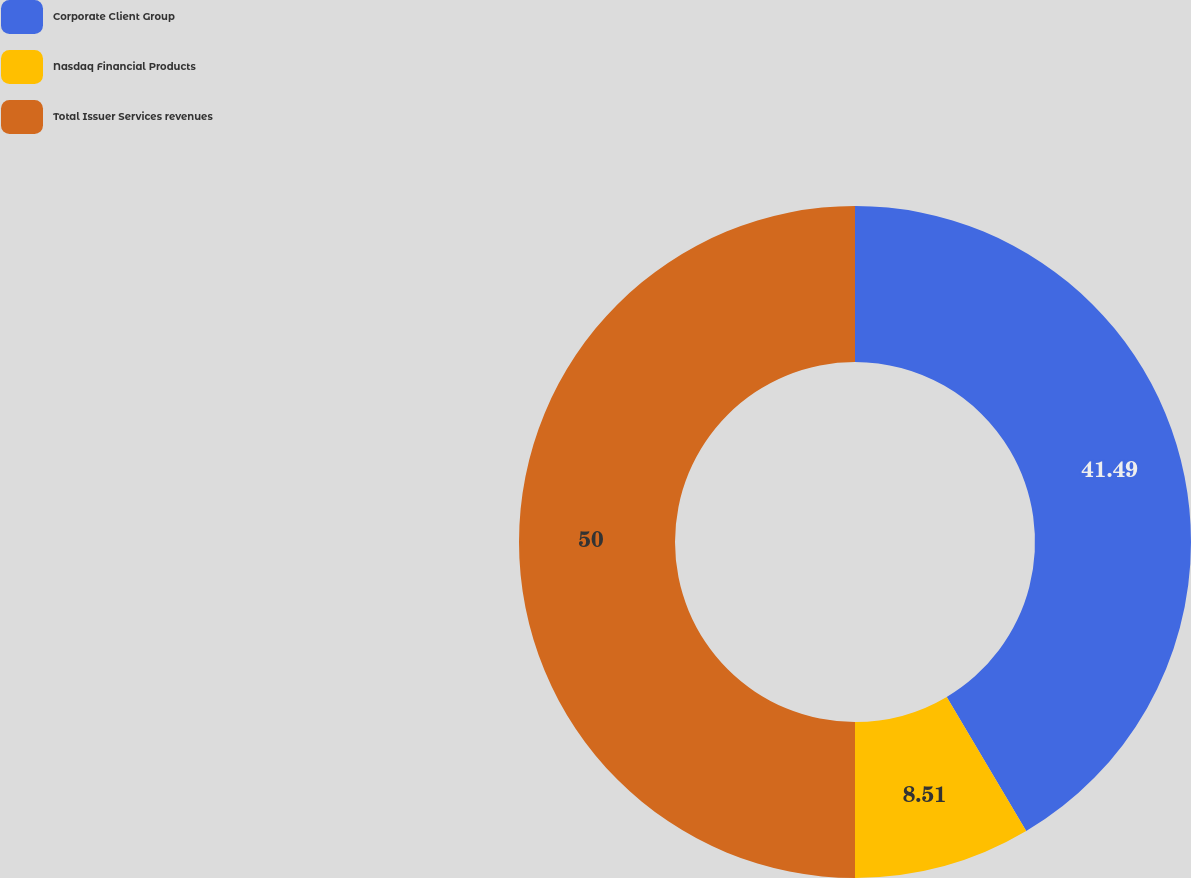Convert chart to OTSL. <chart><loc_0><loc_0><loc_500><loc_500><pie_chart><fcel>Corporate Client Group<fcel>Nasdaq Financial Products<fcel>Total Issuer Services revenues<nl><fcel>41.49%<fcel>8.51%<fcel>50.0%<nl></chart> 